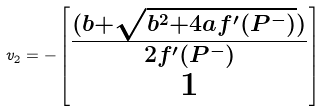<formula> <loc_0><loc_0><loc_500><loc_500>v _ { 2 } = - \begin{bmatrix} \frac { ( b + \sqrt { b ^ { 2 } + 4 a f ^ { \prime } ( P ^ { - } ) } ) } { 2 f ^ { \prime } ( P ^ { - } ) } \\ 1 \end{bmatrix}</formula> 